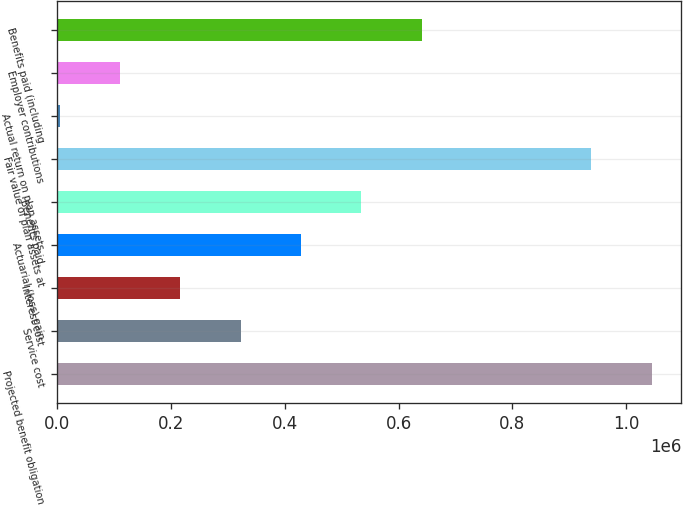<chart> <loc_0><loc_0><loc_500><loc_500><bar_chart><fcel>Projected benefit obligation<fcel>Service cost<fcel>Interest cost<fcel>Actuarial (loss) gain<fcel>Benefits paid<fcel>Fair value of plan assets at<fcel>Actual return on plan assets<fcel>Employer contributions<fcel>Benefits paid (including<nl><fcel>1.0444e+06<fcel>323033<fcel>217175<fcel>428892<fcel>534750<fcel>938544<fcel>5458<fcel>111316<fcel>640608<nl></chart> 